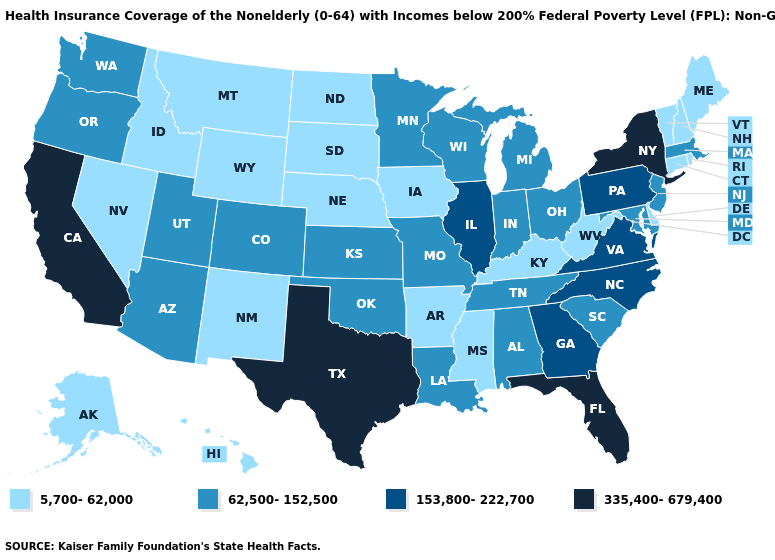Does Kansas have the same value as Massachusetts?
Answer briefly. Yes. Does Virginia have the highest value in the USA?
Concise answer only. No. What is the highest value in states that border Oklahoma?
Be succinct. 335,400-679,400. What is the value of Maryland?
Quick response, please. 62,500-152,500. Does Massachusetts have the lowest value in the Northeast?
Write a very short answer. No. What is the value of Michigan?
Give a very brief answer. 62,500-152,500. Does Hawaii have the lowest value in the USA?
Keep it brief. Yes. What is the lowest value in states that border Florida?
Be succinct. 62,500-152,500. What is the value of South Dakota?
Be succinct. 5,700-62,000. Which states have the lowest value in the West?
Quick response, please. Alaska, Hawaii, Idaho, Montana, Nevada, New Mexico, Wyoming. Is the legend a continuous bar?
Concise answer only. No. Does Pennsylvania have the highest value in the USA?
Keep it brief. No. Name the states that have a value in the range 62,500-152,500?
Keep it brief. Alabama, Arizona, Colorado, Indiana, Kansas, Louisiana, Maryland, Massachusetts, Michigan, Minnesota, Missouri, New Jersey, Ohio, Oklahoma, Oregon, South Carolina, Tennessee, Utah, Washington, Wisconsin. What is the lowest value in the USA?
Quick response, please. 5,700-62,000. What is the value of New Hampshire?
Short answer required. 5,700-62,000. 